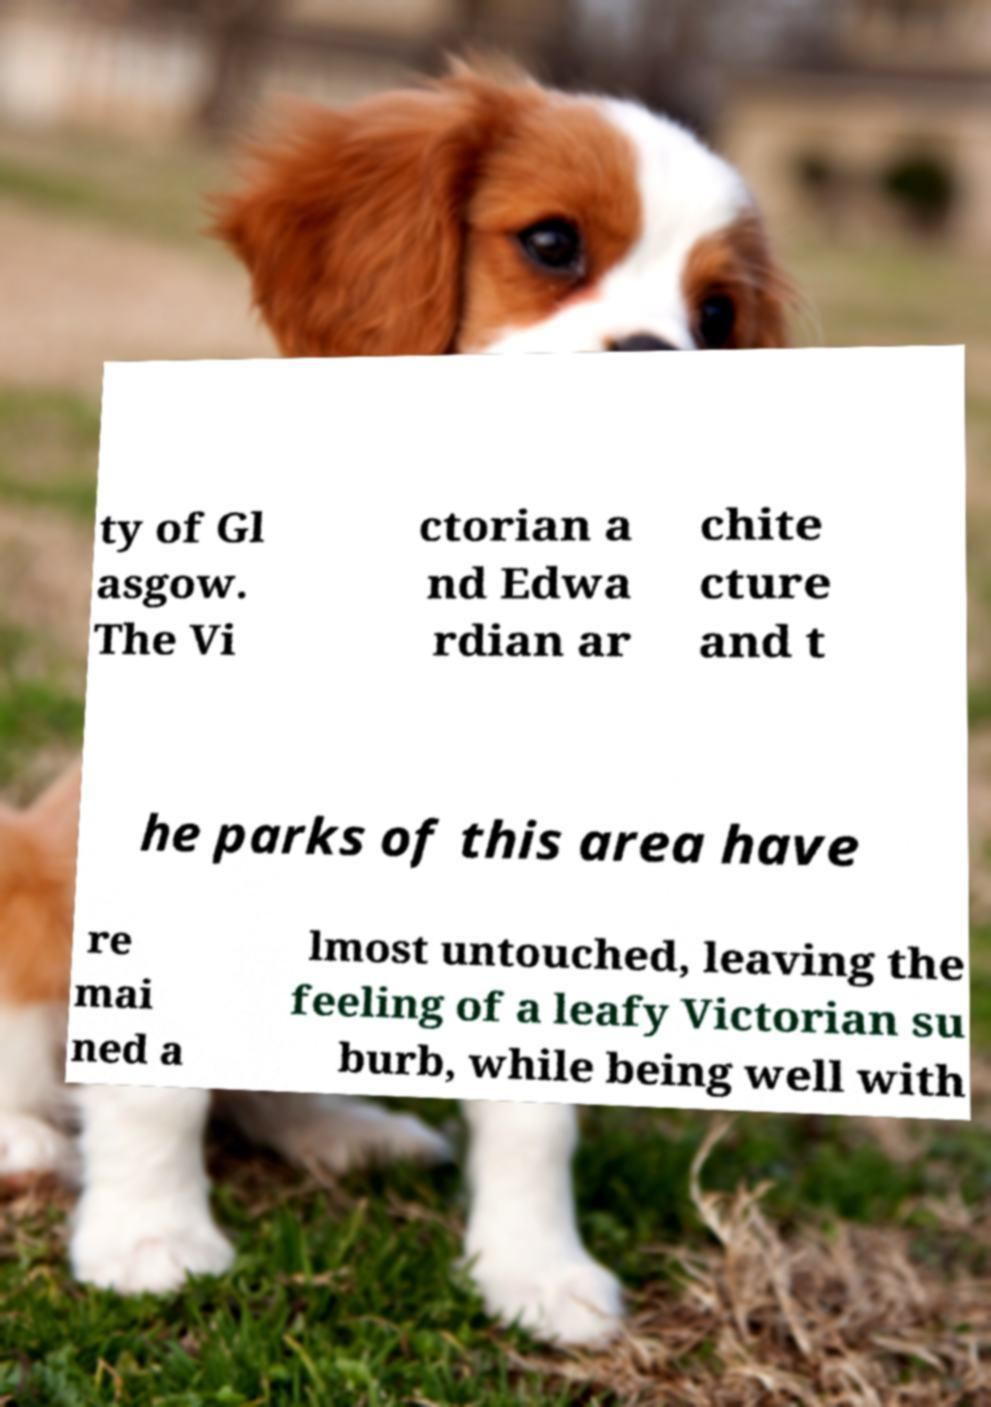Can you accurately transcribe the text from the provided image for me? ty of Gl asgow. The Vi ctorian a nd Edwa rdian ar chite cture and t he parks of this area have re mai ned a lmost untouched, leaving the feeling of a leafy Victorian su burb, while being well with 